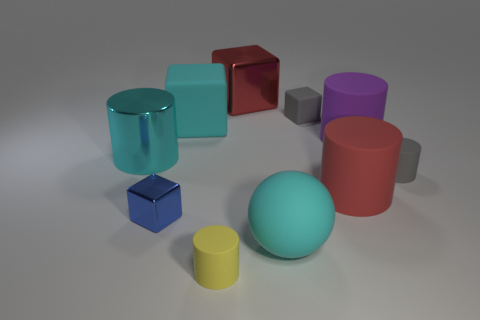There is another big cylinder that is the same material as the red cylinder; what color is it?
Provide a short and direct response. Purple. What number of yellow rubber objects have the same size as the blue metallic thing?
Ensure brevity in your answer.  1. Are the big cylinder that is in front of the tiny gray cylinder and the small blue block made of the same material?
Keep it short and to the point. No. Is the number of blue shiny objects that are behind the gray cube less than the number of small yellow blocks?
Offer a terse response. No. There is a small thing that is to the left of the large cyan block; what shape is it?
Offer a very short reply. Cube. There is a red matte thing that is the same size as the purple matte thing; what is its shape?
Give a very brief answer. Cylinder. Are there any other blue things of the same shape as the small metal object?
Keep it short and to the point. No. Do the cyan matte thing that is in front of the big purple matte object and the small object that is on the left side of the small yellow matte cylinder have the same shape?
Offer a terse response. No. What is the material of the blue object that is the same size as the yellow matte object?
Keep it short and to the point. Metal. How many other objects are the same material as the large purple cylinder?
Give a very brief answer. 6. 